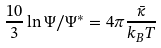<formula> <loc_0><loc_0><loc_500><loc_500>\frac { 1 0 } { 3 } \ln \Psi / \Psi ^ { * } = 4 \pi \frac { \bar { \kappa } } { k _ { B } T }</formula> 